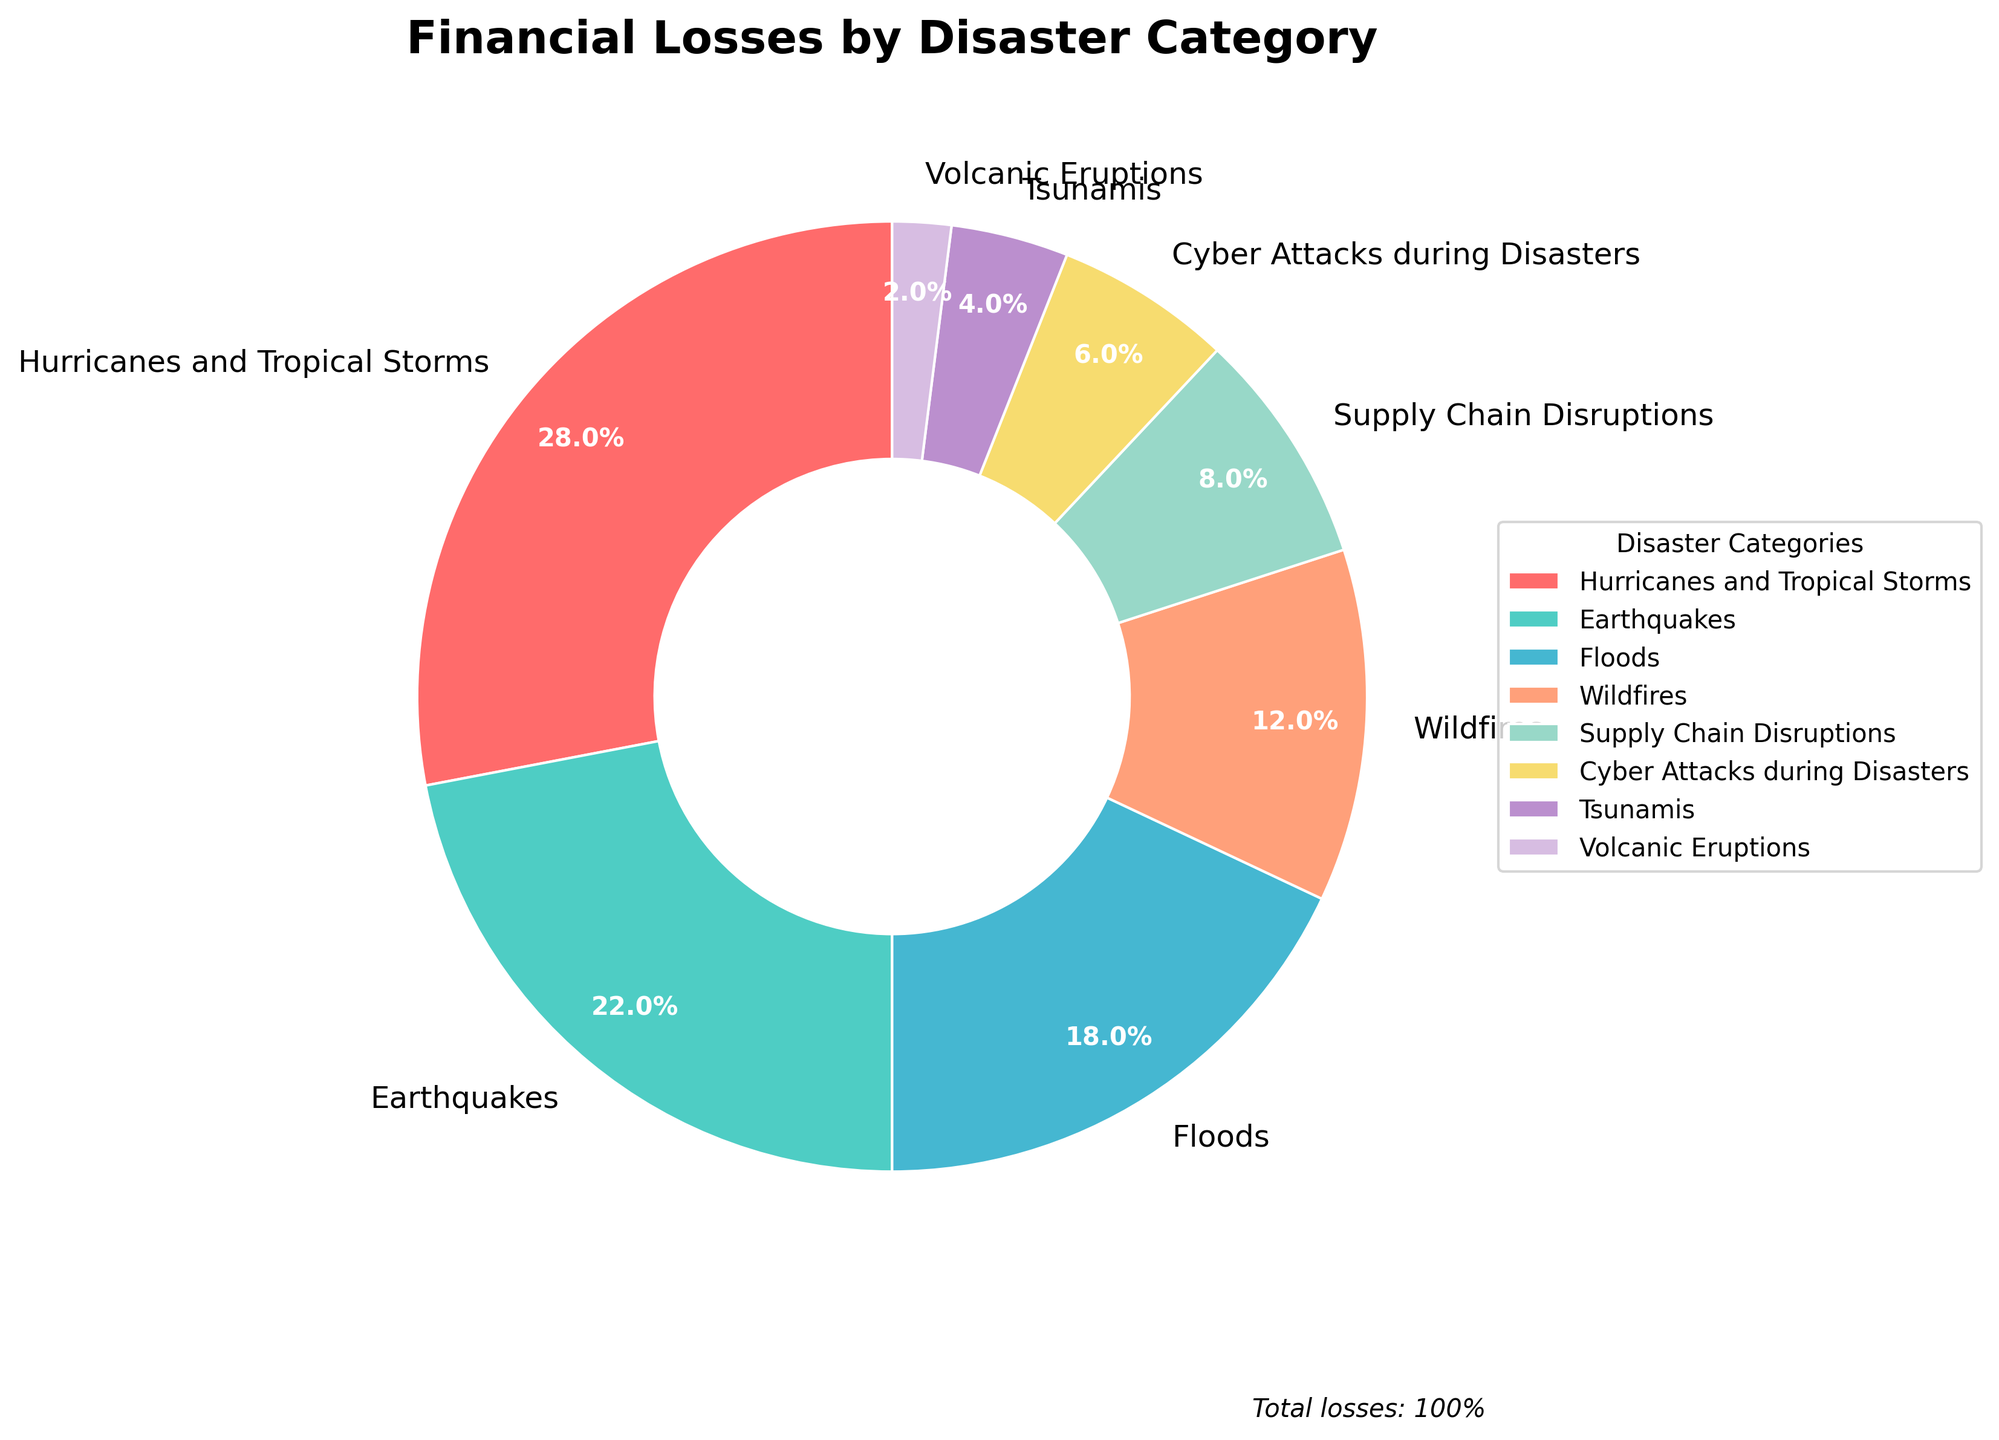What disaster category accounts for the highest percentage of financial losses? The segment labeled "Hurricanes and Tropical Storms" occupies the largest portion of the pie chart, representing the highest percentage.
Answer: Hurricanes and Tropical Storms What is the combined percentage of financial losses due to Earthquakes and Floods? The portion labeled "Earthquakes" accounts for 22%, and "Floods" represent 18%. Adding these together gives 22% + 18%.
Answer: 40% Which disaster category causes the least financial loss? The smallest segment in the pie chart is labeled "Volcanic Eruptions," indicating the lowest percentage of financial loss.
Answer: Volcanic Eruptions What is the difference in financial loss percentages between Wildfires and Cyber Attacks during Disasters? The segment for "Wildfires" represents 12%, while "Cyber Attacks during Disasters" represents 6%. Subtracting these gives 12% - 6%.
Answer: 6% What is the average percentage of financial losses for Supply Chain Disruptions, Cyber Attacks during Disasters, Tsunamis, and Volcanic Eruptions? The percentages for each category are 8% for Supply Chain Disruptions, 6% for Cyber Attacks during Disasters, 4% for Tsunamis, and 2% for Volcanic Eruptions. Adding these together gives 8% + 6% + 4% + 2% = 20%. Dividing by 4 gives the average: 20% / 4.
Answer: 5% Which disaster category has financial losses close to the percentage losses for Earthquakes? The "Floods" segment is 18%, which is the closest percentage to the 22% loss attributed to Earthquakes.
Answer: Floods How much more financial loss is caused by Hurricanes and Tropical Storms compared to Tsunamis? The percentage for "Hurricanes and Tropical Storms" is 28%, while "Tsunamis” is 4%. Subtracting these gives 28% - 4%.
Answer: 24% How do the financial losses due to Wildfires compare to those due to Floods? Wildfires account for 12% and Floods for 18%. Comparing these, Wildfires cause less financial loss than Floods.
Answer: Less How much total percentage of financial loss do Hurricanes and Tropical Storms combined with Cyber Attacks during Disasters account for? The percentages for "Hurricanes and Tropical Storms" and "Cyber Attacks during Disasters" are 28% and 6% respectively. Adding these together gives 28% + 6%.
Answer: 34% What color represents the disaster category with the second lowest percentage of financial losses? The second smallest segment, representing 4% for Tsunamis, is shown in a color corresponding to the pie chart's legend.
Answer: Blue 